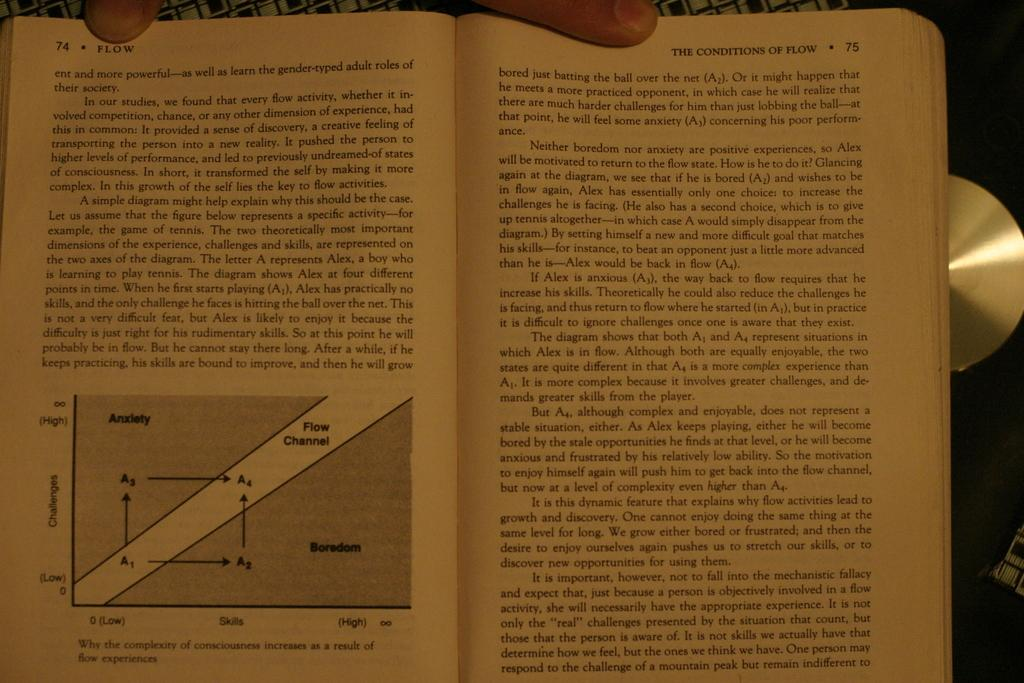<image>
Write a terse but informative summary of the picture. Pages 74 and 75 of a book discuss the topic of flow. 